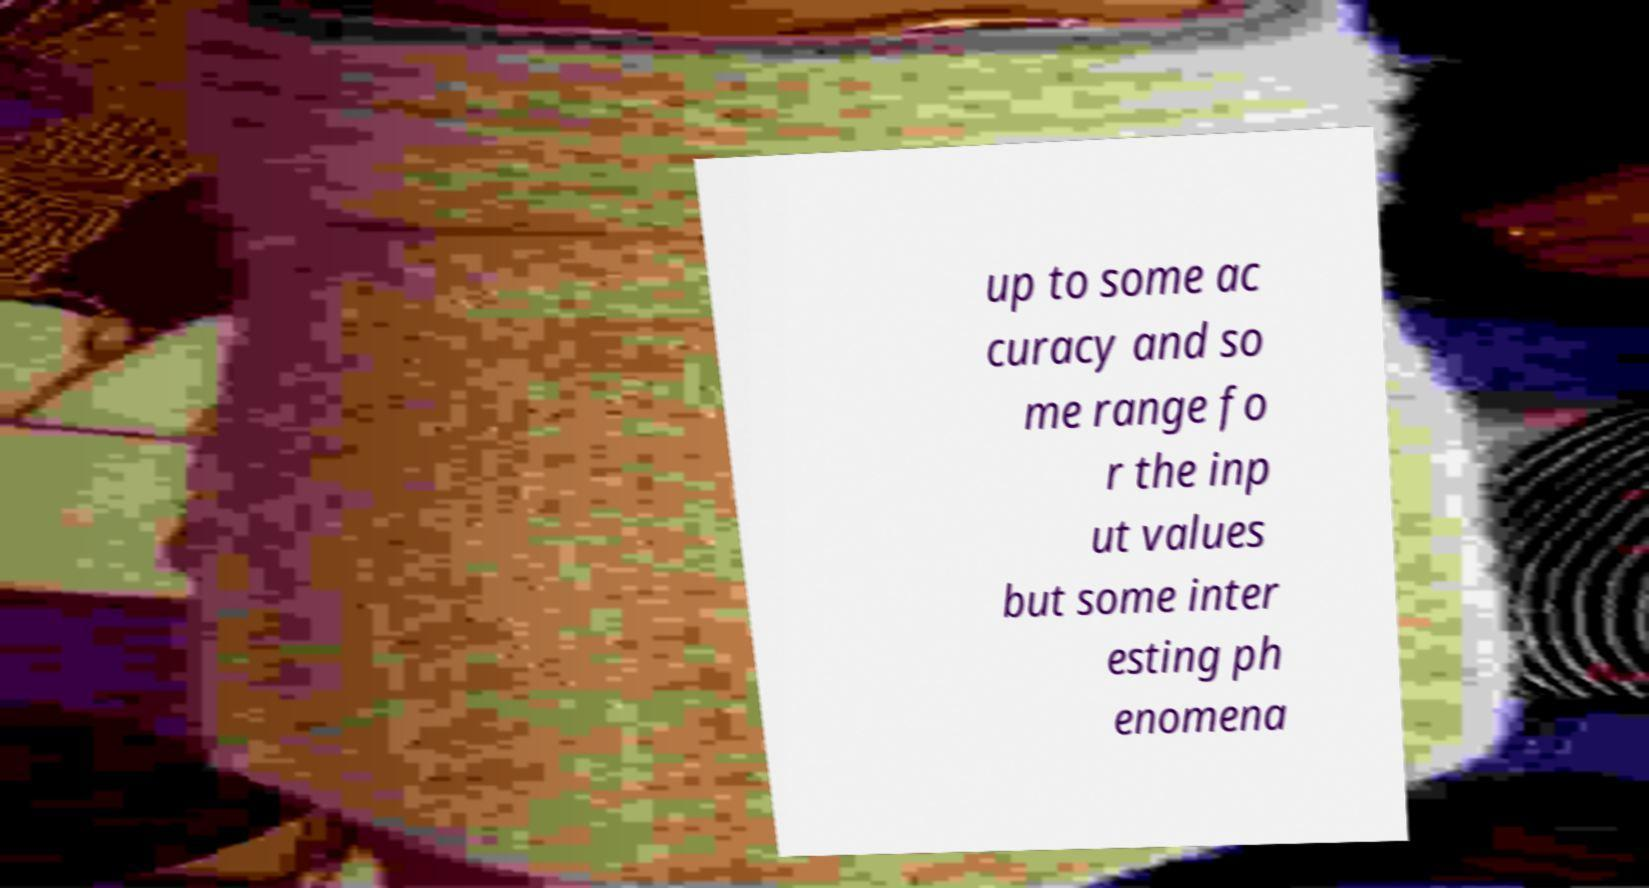Can you accurately transcribe the text from the provided image for me? up to some ac curacy and so me range fo r the inp ut values but some inter esting ph enomena 